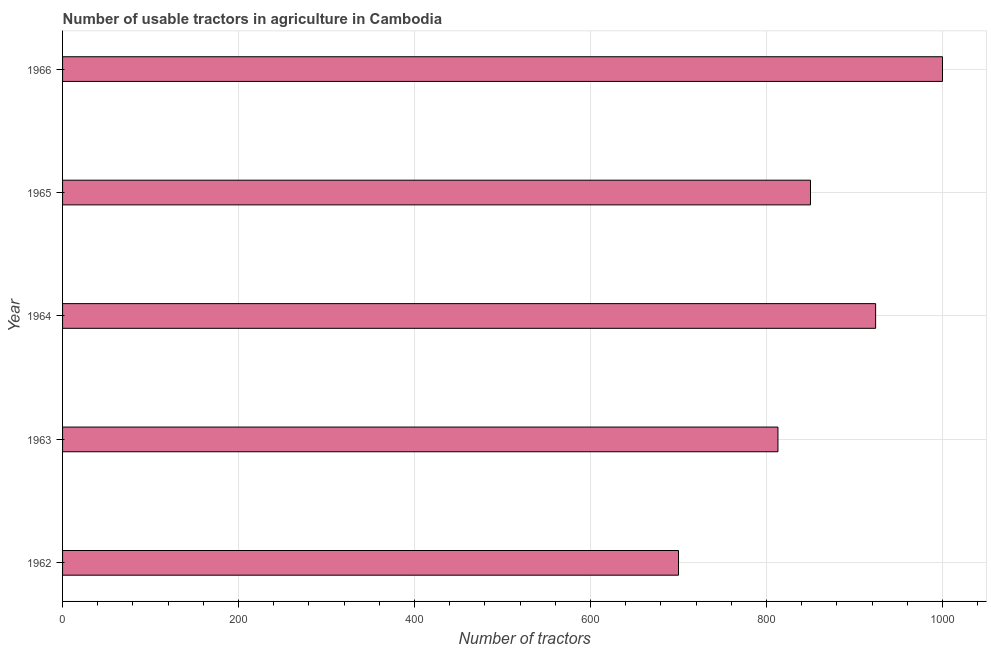What is the title of the graph?
Provide a succinct answer. Number of usable tractors in agriculture in Cambodia. What is the label or title of the X-axis?
Give a very brief answer. Number of tractors. What is the number of tractors in 1965?
Offer a terse response. 850. Across all years, what is the minimum number of tractors?
Provide a short and direct response. 700. In which year was the number of tractors maximum?
Your answer should be very brief. 1966. What is the sum of the number of tractors?
Your answer should be very brief. 4287. What is the difference between the number of tractors in 1962 and 1963?
Keep it short and to the point. -113. What is the average number of tractors per year?
Your answer should be compact. 857. What is the median number of tractors?
Keep it short and to the point. 850. In how many years, is the number of tractors greater than 360 ?
Your answer should be compact. 5. What is the ratio of the number of tractors in 1962 to that in 1965?
Your response must be concise. 0.82. Is the difference between the number of tractors in 1962 and 1964 greater than the difference between any two years?
Your response must be concise. No. What is the difference between the highest and the second highest number of tractors?
Provide a succinct answer. 76. Is the sum of the number of tractors in 1962 and 1965 greater than the maximum number of tractors across all years?
Offer a very short reply. Yes. What is the difference between the highest and the lowest number of tractors?
Provide a succinct answer. 300. In how many years, is the number of tractors greater than the average number of tractors taken over all years?
Your answer should be very brief. 2. How many bars are there?
Offer a very short reply. 5. How many years are there in the graph?
Your answer should be compact. 5. What is the Number of tractors of 1962?
Make the answer very short. 700. What is the Number of tractors in 1963?
Ensure brevity in your answer.  813. What is the Number of tractors of 1964?
Provide a succinct answer. 924. What is the Number of tractors in 1965?
Make the answer very short. 850. What is the Number of tractors of 1966?
Offer a very short reply. 1000. What is the difference between the Number of tractors in 1962 and 1963?
Provide a succinct answer. -113. What is the difference between the Number of tractors in 1962 and 1964?
Provide a succinct answer. -224. What is the difference between the Number of tractors in 1962 and 1965?
Make the answer very short. -150. What is the difference between the Number of tractors in 1962 and 1966?
Make the answer very short. -300. What is the difference between the Number of tractors in 1963 and 1964?
Offer a terse response. -111. What is the difference between the Number of tractors in 1963 and 1965?
Your answer should be compact. -37. What is the difference between the Number of tractors in 1963 and 1966?
Give a very brief answer. -187. What is the difference between the Number of tractors in 1964 and 1965?
Keep it short and to the point. 74. What is the difference between the Number of tractors in 1964 and 1966?
Offer a terse response. -76. What is the difference between the Number of tractors in 1965 and 1966?
Keep it short and to the point. -150. What is the ratio of the Number of tractors in 1962 to that in 1963?
Provide a short and direct response. 0.86. What is the ratio of the Number of tractors in 1962 to that in 1964?
Offer a terse response. 0.76. What is the ratio of the Number of tractors in 1962 to that in 1965?
Your answer should be very brief. 0.82. What is the ratio of the Number of tractors in 1963 to that in 1965?
Give a very brief answer. 0.96. What is the ratio of the Number of tractors in 1963 to that in 1966?
Offer a very short reply. 0.81. What is the ratio of the Number of tractors in 1964 to that in 1965?
Ensure brevity in your answer.  1.09. What is the ratio of the Number of tractors in 1964 to that in 1966?
Your answer should be compact. 0.92. 